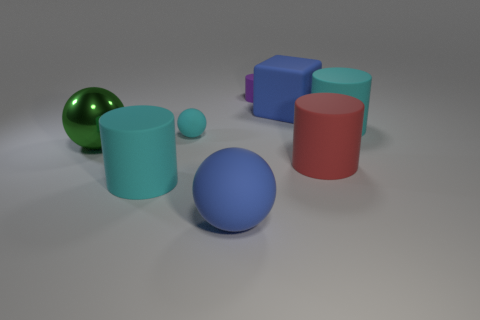Can you describe the textures of the objects in the image? Certainly! In the image, there's a variety of textures present. The green sphere has a reflective, shiny surface, suggesting a smooth and maybe metallic texture. The cylinders and the cubes display a more matte finish, indicating a less reflective, possibly plastic or rubber-like material. The large blue sphere has a texture that looks smooth but not highly reflective, possibly a painted surface. 